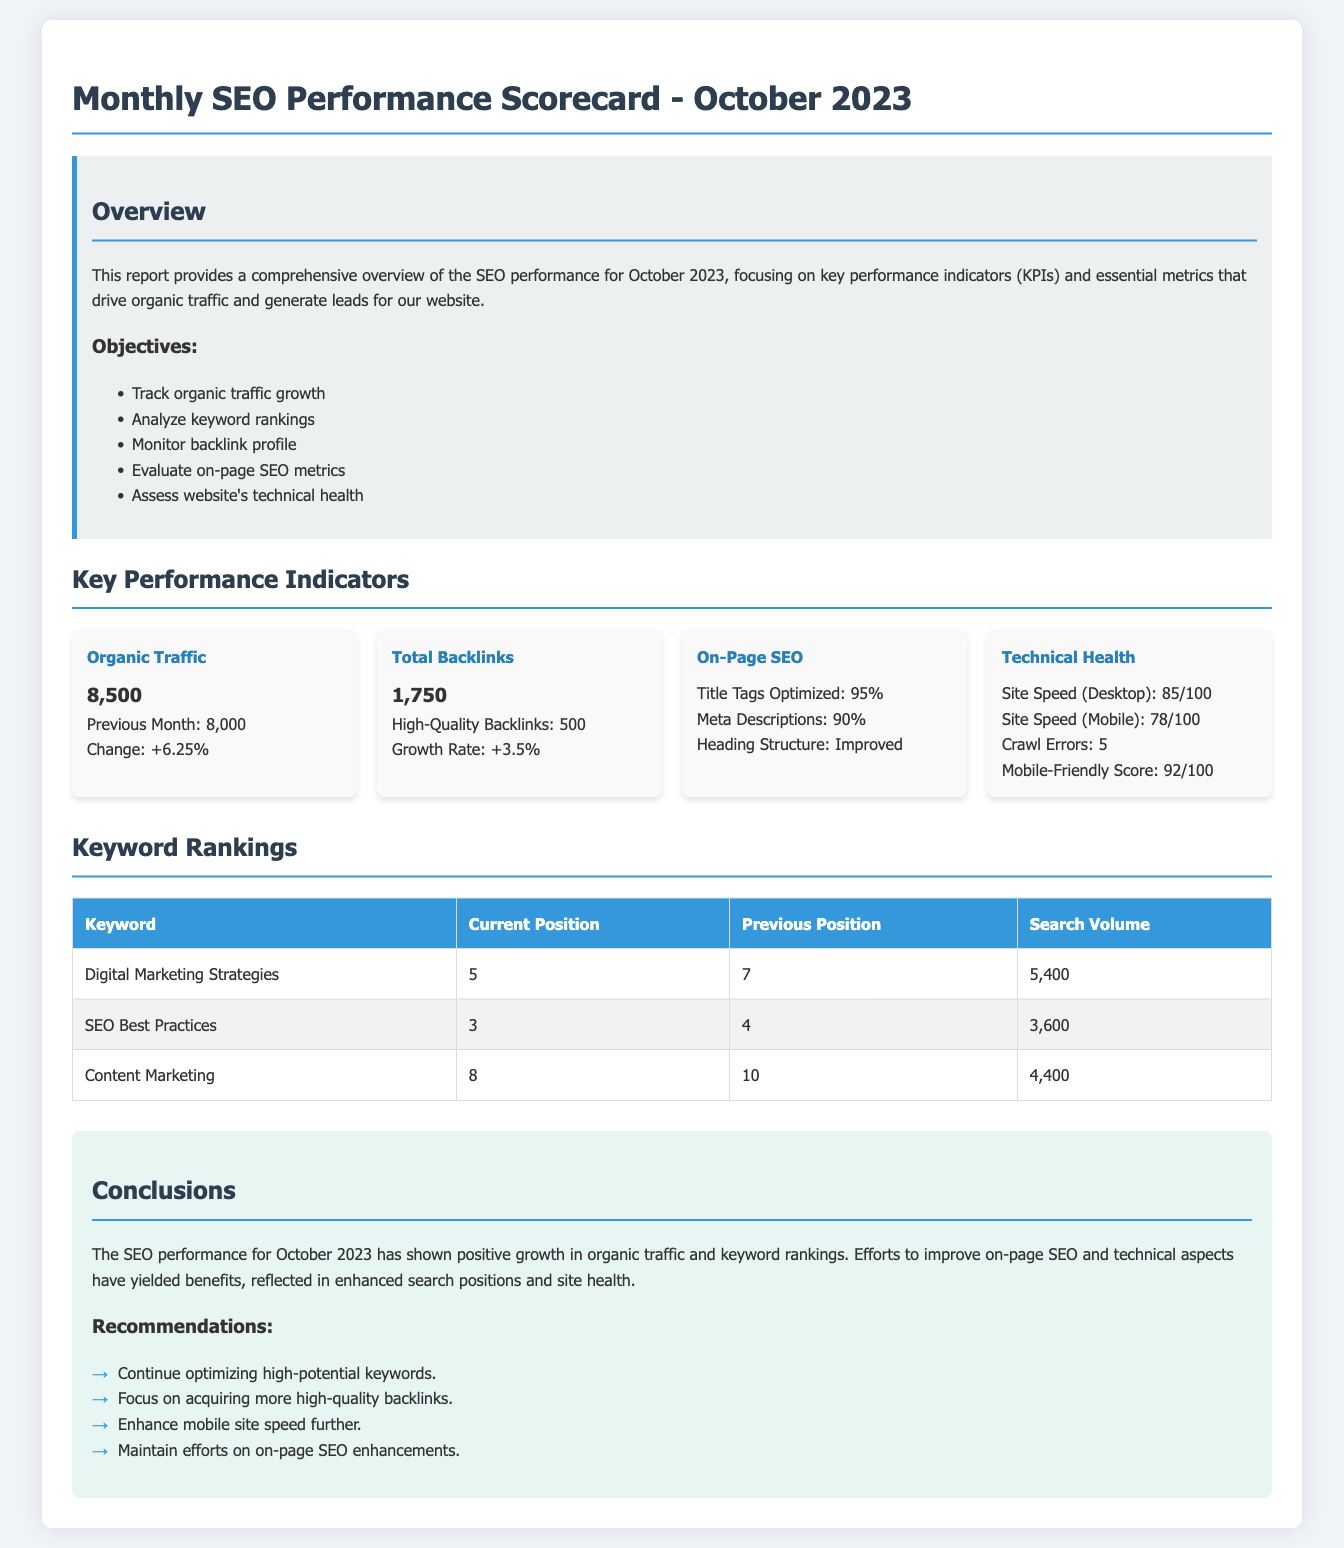What is the organic traffic for October 2023? The organic traffic for October 2023 is explicitly stated in the document as 8,500.
Answer: 8,500 What is the change in organic traffic from the previous month? The document mentions the change in organic traffic from the previous month as +6.25%.
Answer: +6.25% How many high-quality backlinks were there? The number of high-quality backlinks is provided as 500.
Answer: 500 What is the site's mobile-friendly score? The mobile-friendly score is indicated in the document as 92/100.
Answer: 92/100 Which keyword improved its position from the previous month? The keyword "Digital Marketing Strategies" improved its position from 7 to 5.
Answer: Digital Marketing Strategies How many total backlinks are listed? The document states the total number of backlinks as 1,750.
Answer: 1,750 What percentage of title tags are optimized? The percentage of optimized title tags is listed as 95%.
Answer: 95% What is the current position of the keyword "SEO Best Practices"? The current position of "SEO Best Practices" is noted as 3.
Answer: 3 What is one of the objectives of the SEO performance report? One of the objectives is to track organic traffic growth.
Answer: Track organic traffic growth What is one recommendation from the conclusions section? One recommendation mentioned is to enhance mobile site speed further.
Answer: Enhance mobile site speed further 